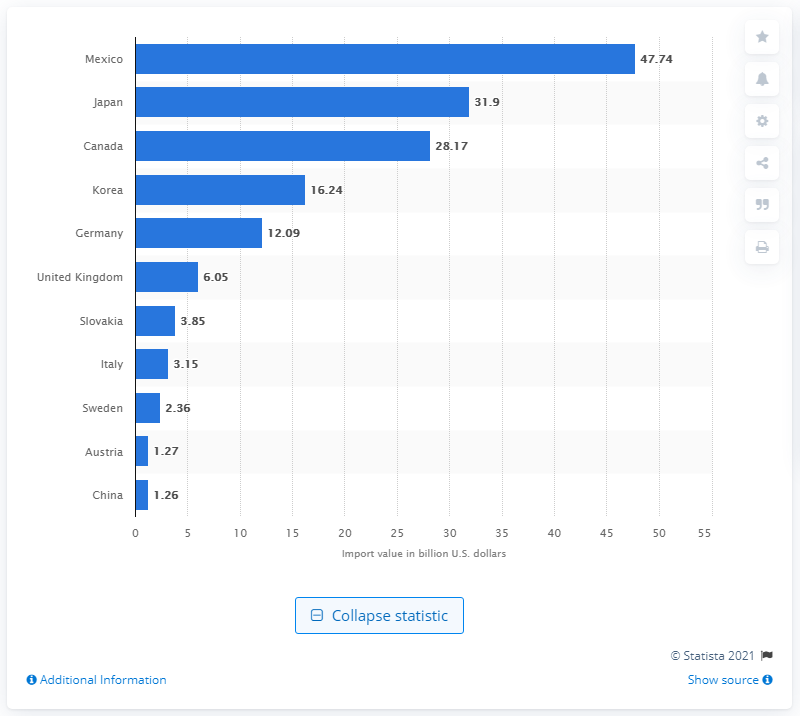Outline some significant characteristics in this image. In 2020, the United States imported the largest number of light vehicles from Mexico. In 2020, the value of Mexico's light vehicle imports was 47.74 billion dollars. 